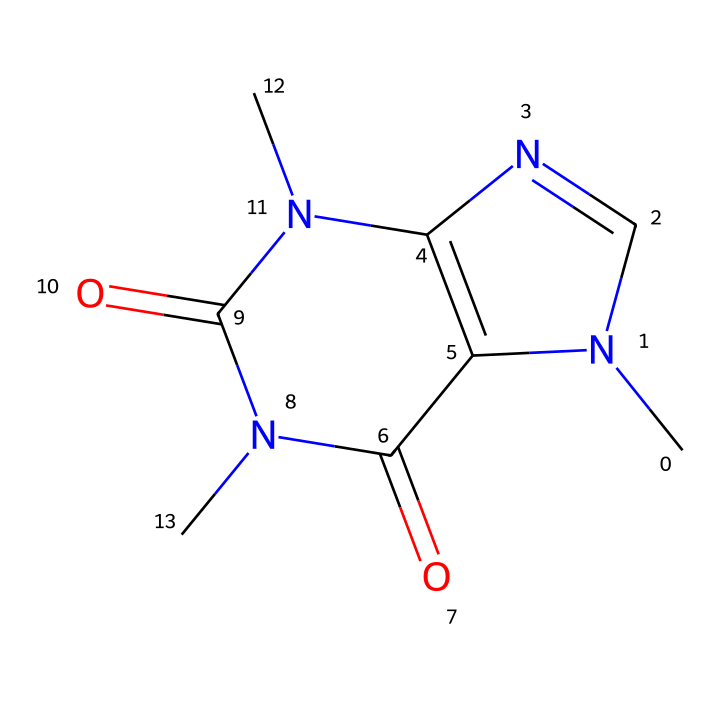What is the molecular formula of caffeine? To find the molecular formula, count the number of each type of atom in the SMILES representation. The SMILES indicates 8 carbon (C), 10 hydrogen (H), 4 nitrogen (N), and 2 oxygen (O) atoms. Putting this together gives C8H10N4O2.
Answer: C8H10N4O2 How many nitrogen atoms are present in caffeine? In the provided SMILES structure, there are four nitrogen (N) atoms clearly indicated.
Answer: 4 What type of compound is caffeine classified as? Caffeine has a combination of nitrogen and aromatic rings in its structure. It is classified as an alkaloid, which is known for having physiological effects.
Answer: alkaloid Does caffeine have any aromatic rings in its structure? The presence of conjugated pi systems and specific cyclic arrangements of carbon atoms in the structure indicates the existence of aromatic rings. Caffeine indeed has aromatic characteristics.
Answer: yes How many rings are in the caffeine structure? The SMILES representation shows two interconnected ring structures, which can be seen from the cycle formations and bond arrangements.
Answer: 2 What type of bonding can be inferred from the presence of the nitrogen atoms in caffeine? Nitrogen atoms in the structure suggest the presence of basic amine functionalities, which can participate in hydrogen bonding and affect the overall solubility and reactivity of the molecule.
Answer: hydrogen bonding What is the structural feature that makes caffeine a stimulant? The methyl groups attached to the nitrogen atoms and the unique arrangement of the rings allow caffeine to interact with adenosine receptors in the brain, enabling its stimulant properties.
Answer: methyl groups 